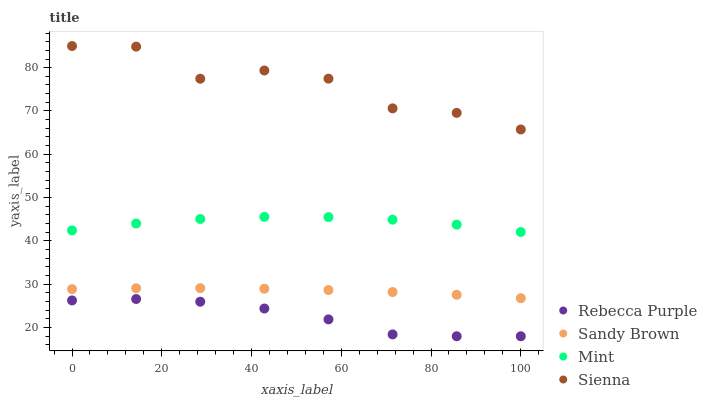Does Rebecca Purple have the minimum area under the curve?
Answer yes or no. Yes. Does Sienna have the maximum area under the curve?
Answer yes or no. Yes. Does Mint have the minimum area under the curve?
Answer yes or no. No. Does Mint have the maximum area under the curve?
Answer yes or no. No. Is Sandy Brown the smoothest?
Answer yes or no. Yes. Is Sienna the roughest?
Answer yes or no. Yes. Is Mint the smoothest?
Answer yes or no. No. Is Mint the roughest?
Answer yes or no. No. Does Rebecca Purple have the lowest value?
Answer yes or no. Yes. Does Mint have the lowest value?
Answer yes or no. No. Does Sienna have the highest value?
Answer yes or no. Yes. Does Mint have the highest value?
Answer yes or no. No. Is Rebecca Purple less than Sandy Brown?
Answer yes or no. Yes. Is Sandy Brown greater than Rebecca Purple?
Answer yes or no. Yes. Does Rebecca Purple intersect Sandy Brown?
Answer yes or no. No. 